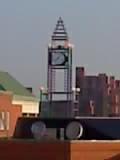Where is the clock?
Quick response, please. On tower. Is there a clock in this photo?
Write a very short answer. Yes. Is there a tower on this picture?
Be succinct. Yes. 